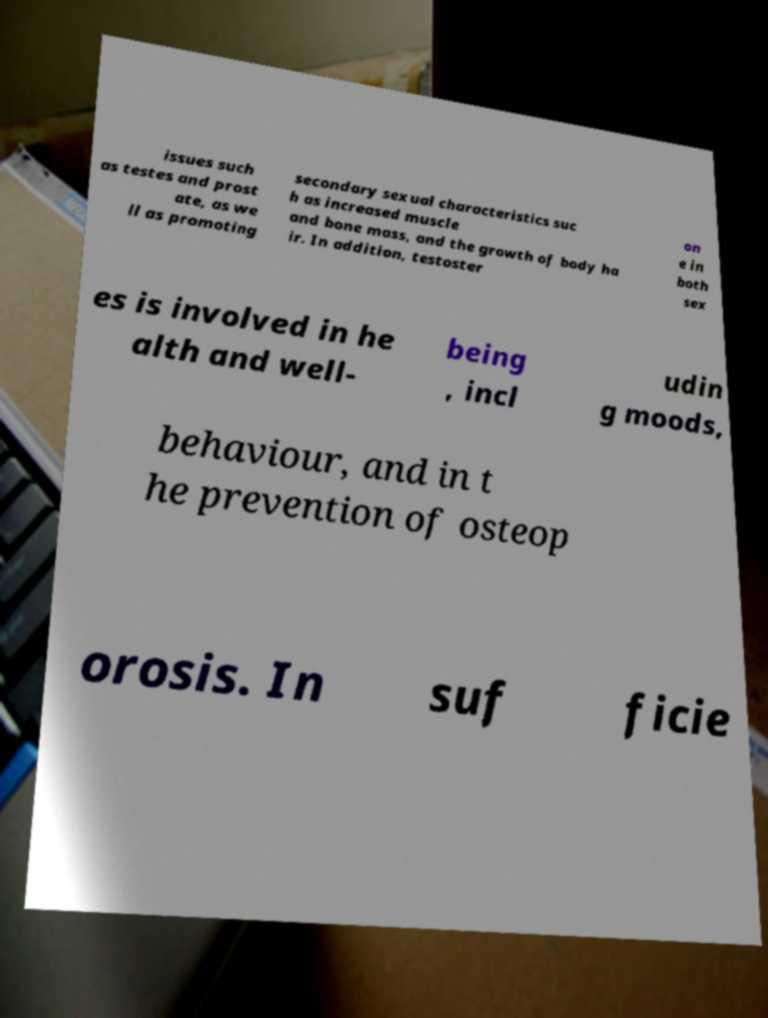What messages or text are displayed in this image? I need them in a readable, typed format. issues such as testes and prost ate, as we ll as promoting secondary sexual characteristics suc h as increased muscle and bone mass, and the growth of body ha ir. In addition, testoster on e in both sex es is involved in he alth and well- being , incl udin g moods, behaviour, and in t he prevention of osteop orosis. In suf ficie 